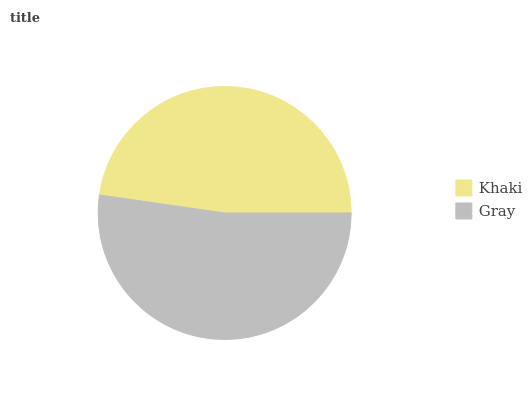Is Khaki the minimum?
Answer yes or no. Yes. Is Gray the maximum?
Answer yes or no. Yes. Is Gray the minimum?
Answer yes or no. No. Is Gray greater than Khaki?
Answer yes or no. Yes. Is Khaki less than Gray?
Answer yes or no. Yes. Is Khaki greater than Gray?
Answer yes or no. No. Is Gray less than Khaki?
Answer yes or no. No. Is Gray the high median?
Answer yes or no. Yes. Is Khaki the low median?
Answer yes or no. Yes. Is Khaki the high median?
Answer yes or no. No. Is Gray the low median?
Answer yes or no. No. 